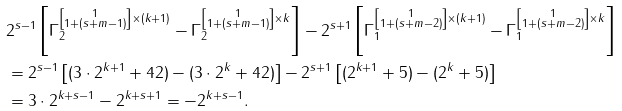Convert formula to latex. <formula><loc_0><loc_0><loc_500><loc_500>& 2 ^ { s - 1 } \left [ \Gamma _ { 2 } ^ { \left [ \substack { 1 \\ 1 + ( s + m - 1 ) } \right ] \times ( k + 1 ) } - \Gamma _ { 2 } ^ { \left [ \substack { 1 \\ 1 + ( s + m - 1 ) } \right ] \times k } \right ] - 2 ^ { s + 1 } \left [ \Gamma _ { 1 } ^ { \left [ \substack { 1 \\ 1 + ( s + m - 2 ) } \right ] \times ( k + 1 ) } - \Gamma _ { 1 } ^ { \left [ \substack { 1 \\ 1 + ( s + m - 2 ) } \right ] \times k } \right ] \\ & = 2 ^ { s - 1 } \left [ ( 3 \cdot 2 ^ { k + 1 } + 4 2 ) - ( 3 \cdot 2 ^ { k } + 4 2 ) \right ] - 2 ^ { s + 1 } \left [ ( 2 ^ { k + 1 } + 5 ) - ( 2 ^ { k } + 5 ) \right ] \\ & = 3 \cdot 2 ^ { k + s - 1 } - 2 ^ { k + s + 1 } = - 2 ^ { k + s - 1 } . \\ &</formula> 